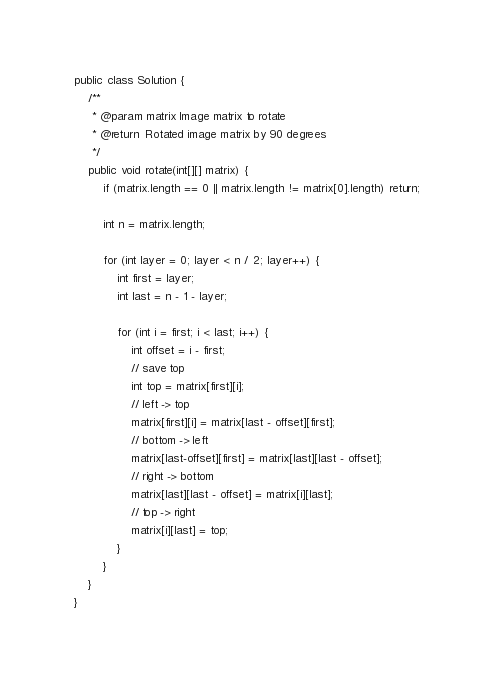Convert code to text. <code><loc_0><loc_0><loc_500><loc_500><_Java_>public class Solution {
    /**
     * @param matrix Image matrix to rotate
     * @return  Rotated image matrix by 90 degrees
     */
    public void rotate(int[][] matrix) {
        if (matrix.length == 0 || matrix.length != matrix[0].length) return;

        int n = matrix.length;

        for (int layer = 0; layer < n / 2; layer++) {
            int first = layer;
            int last = n - 1 - layer;

            for (int i = first; i < last; i++) {
                int offset = i - first;
                // save top
                int top = matrix[first][i];
                // left -> top
                matrix[first][i] = matrix[last - offset][first];
                // bottom -> left
                matrix[last-offset][first] = matrix[last][last - offset];
                // right -> bottom
                matrix[last][last - offset] = matrix[i][last];
                // top -> right
                matrix[i][last] = top;
            }
        }
    }
}
</code> 